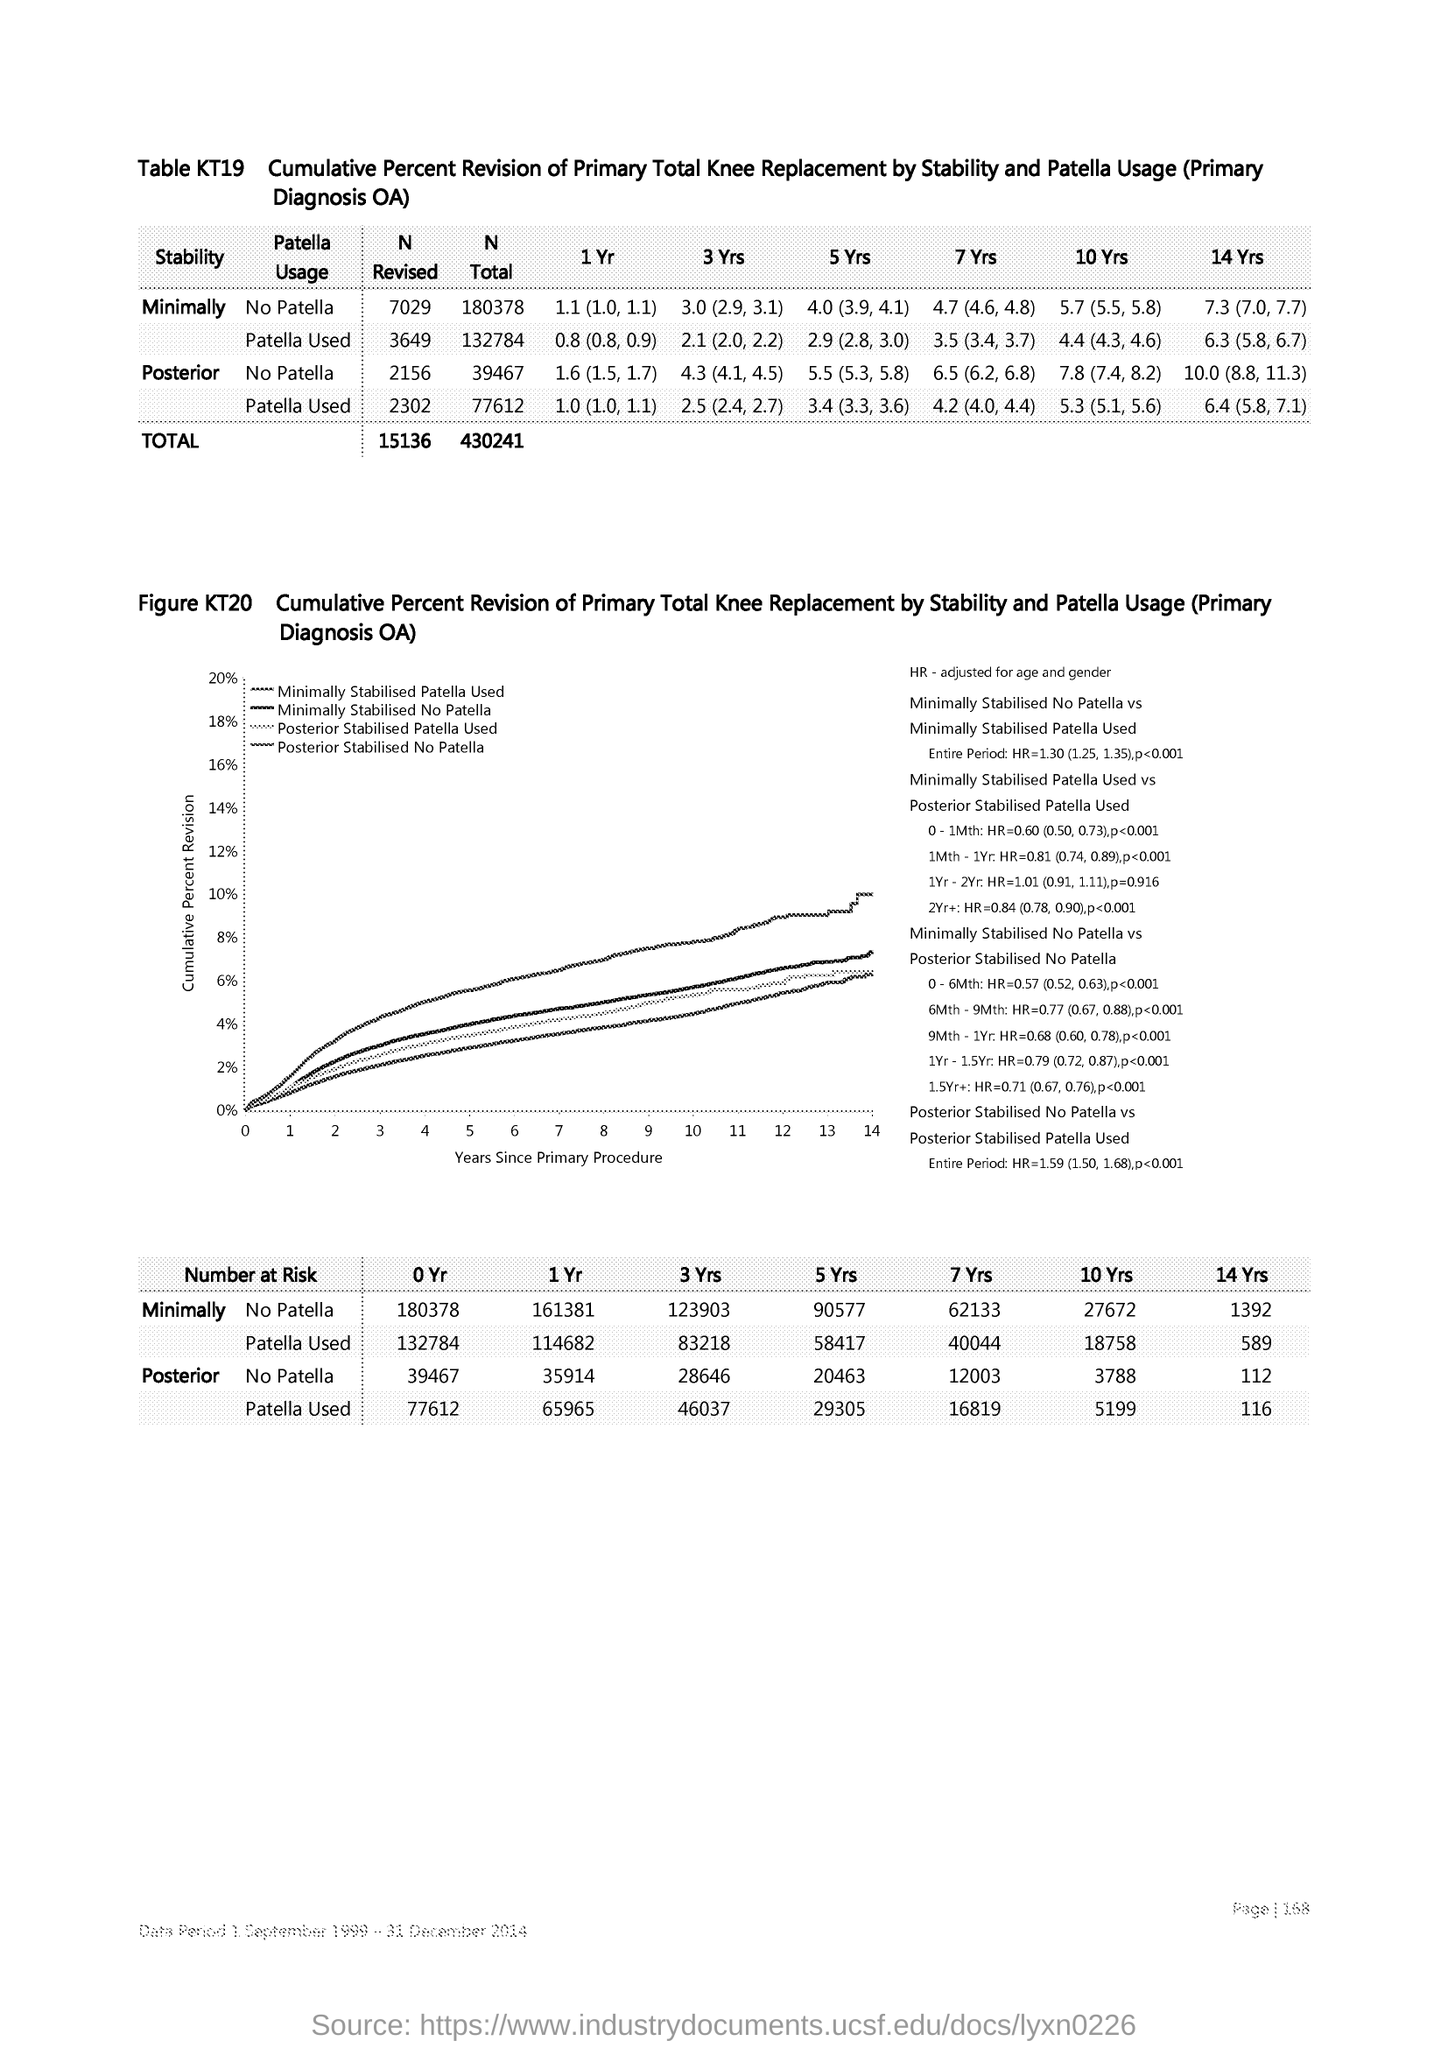What is plotted in the y-axis?
Provide a short and direct response. Cumulative Percent Revision. What is plotted in the x-axis ?
Provide a short and direct response. Years since Primary Procedure. 